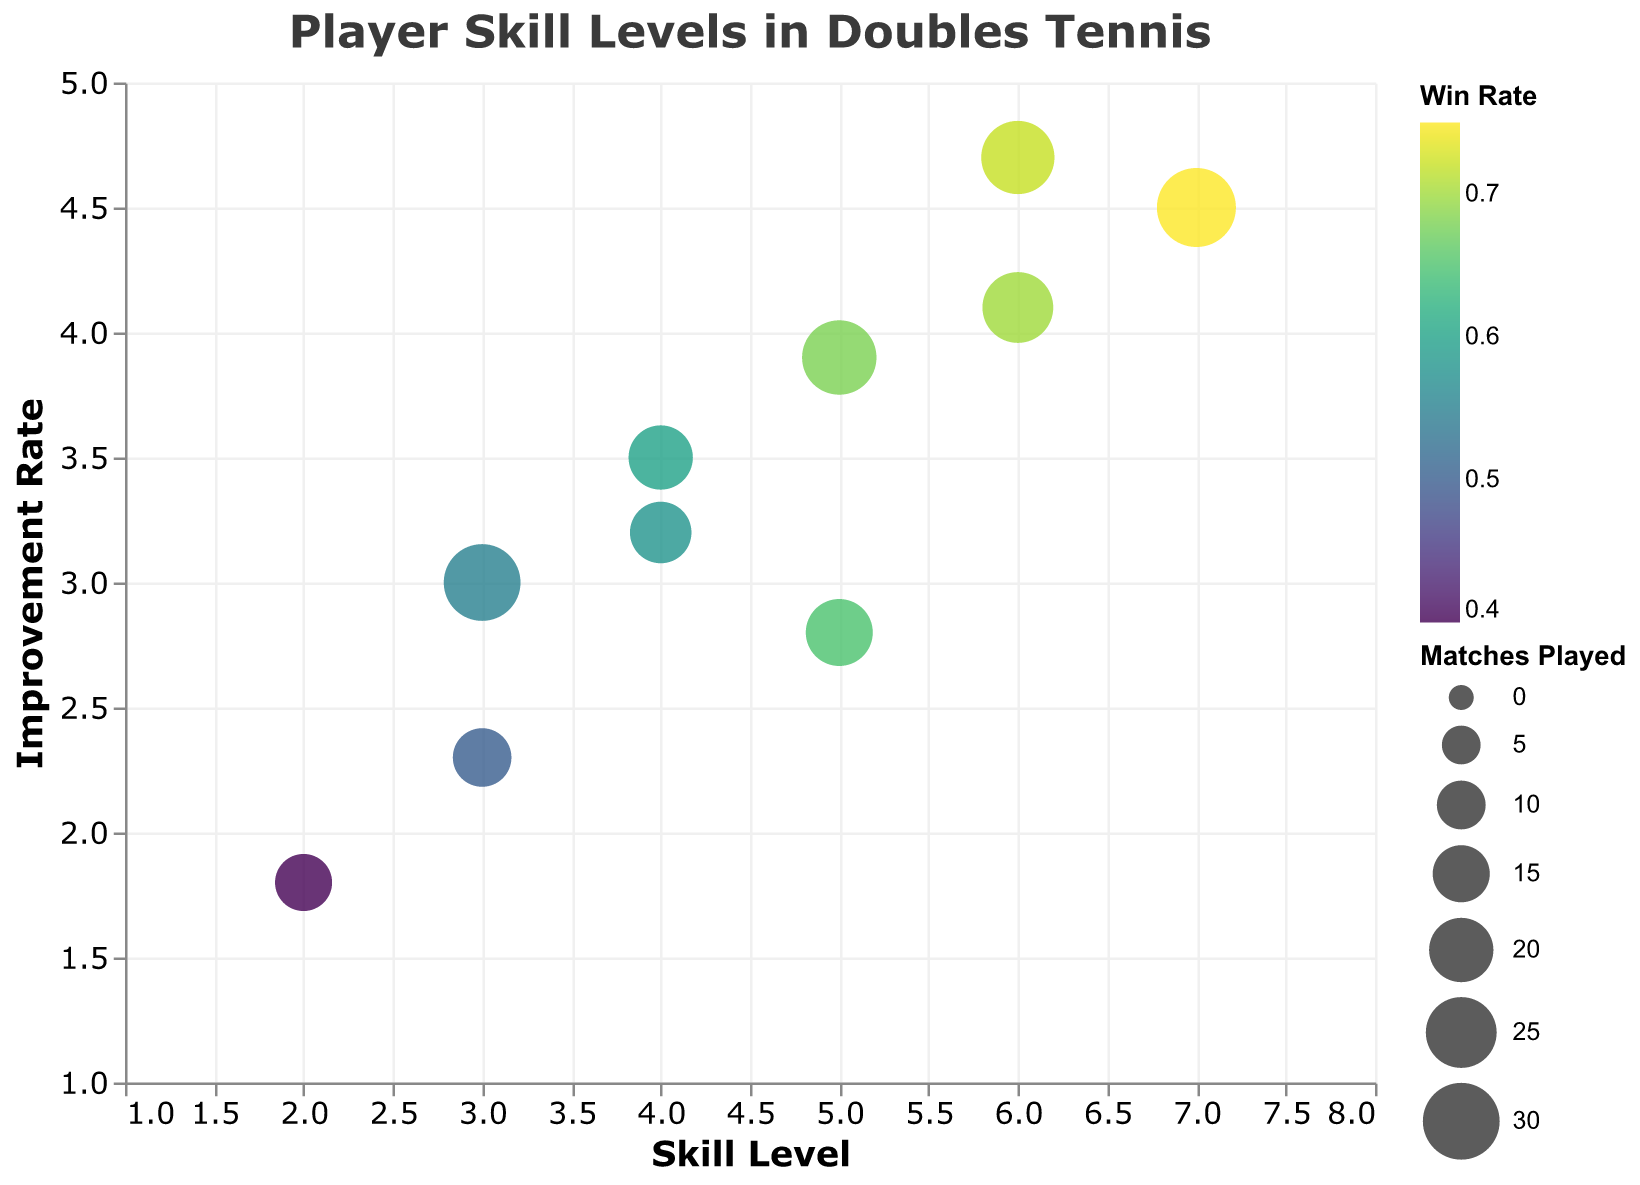Is there a correlation between skill level and improvement rate? By observing the positions of the bubbles on the x-axis (skill level) and y-axis (improvement rate), one can assess if higher skill levels tend to correspond to higher improvement rates. The general trend can be seen visually.
Answer: Yes, generally, higher skill levels tend to have higher improvement rates Who has the highest improvement rate, and what is their win rate? The highest improvement rate is represented by the highest point on the y-axis (improvement rate). The tooltip information will then show the corresponding player and win rate.
Answer: Olivia Harris, 0.75 Which player has the highest skill level, and how many matches have they played? The highest point on the x-axis (skill level) represents the player with the highest skill level. The size of the bubble indicates the number of matches played, and hovering over the bubble will provide the exact value.
Answer: Olivia Harris, 32 matches How many players have a skill level above 5? Count the number of bubbles that lie above the skill level value of 5 on the x-axis.
Answer: 3 players Is there a player with a lower skill level but a higher improvement rate than John Smith? Compare John Smith's bubble (skill level = 4, improvement rate = 3.5) with other bubbles to see if any have both a lower skill level and a higher improvement rate.
Answer: Ava Lewis Which player has played the fewest matches, and what is their skill level? Find the smallest bubble (indicating the fewest matches played) and check the tooltip information for the player's name and skill level.
Answer: Daniel Brown, skill level 2 What is the average win rate of players with a skill level of 5? Identify the players with a skill level of 5, sum their win rates, and divide by the number of those players.
Answer: Emily Davis (0.65) and Ava Lewis (0.68); average is (0.65 + 0.68) / 2 = 0.665 Which player has the largest mismatch between their skill level and the improvement rate (in either direction)? Analyze the differences between skill levels and improvement rates across all players to see who has the most significant disparity.
Answer: Daniel Brown (skill level 2, improvement rate 1.8) What is the average number of matches played by players with a win rate above 0.7? Identify the players with win rates above 0.7, sum the matches played, and divide by the number of those players.
Answer: Michael Johnson (25 matches), Olivia Harris (32 matches), Isabella Robinson (27 matches); average is (25 + 32 + 27)/3 = 28 